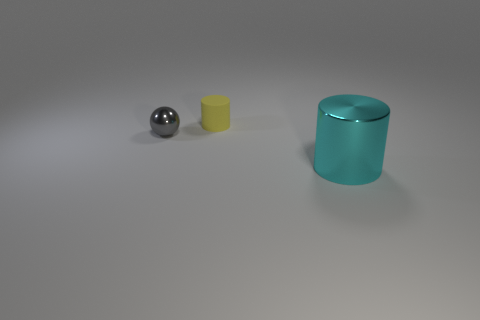Add 1 metallic spheres. How many objects exist? 4 Subtract all yellow cylinders. Subtract all green cubes. How many cylinders are left? 1 Subtract all red cubes. How many green cylinders are left? 0 Subtract all spheres. Subtract all big cyan metal objects. How many objects are left? 1 Add 3 large cyan objects. How many large cyan objects are left? 4 Add 2 small blue shiny cylinders. How many small blue shiny cylinders exist? 2 Subtract all cyan cylinders. How many cylinders are left? 1 Subtract 1 cyan cylinders. How many objects are left? 2 Subtract all cylinders. How many objects are left? 1 Subtract 1 balls. How many balls are left? 0 